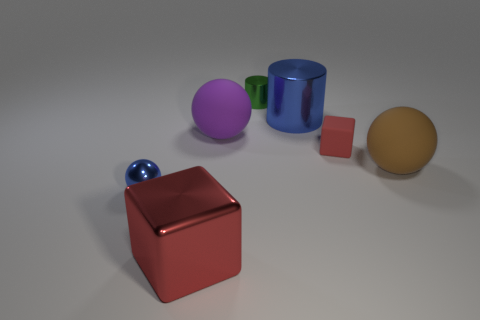Subtract all big balls. How many balls are left? 1 Subtract all blue balls. How many balls are left? 2 Subtract all cyan balls. Subtract all green cylinders. How many balls are left? 3 Add 3 big green things. How many objects exist? 10 Subtract all cylinders. How many objects are left? 5 Add 2 rubber objects. How many rubber objects are left? 5 Add 7 tiny things. How many tiny things exist? 10 Subtract 2 red cubes. How many objects are left? 5 Subtract all rubber cylinders. Subtract all tiny green things. How many objects are left? 6 